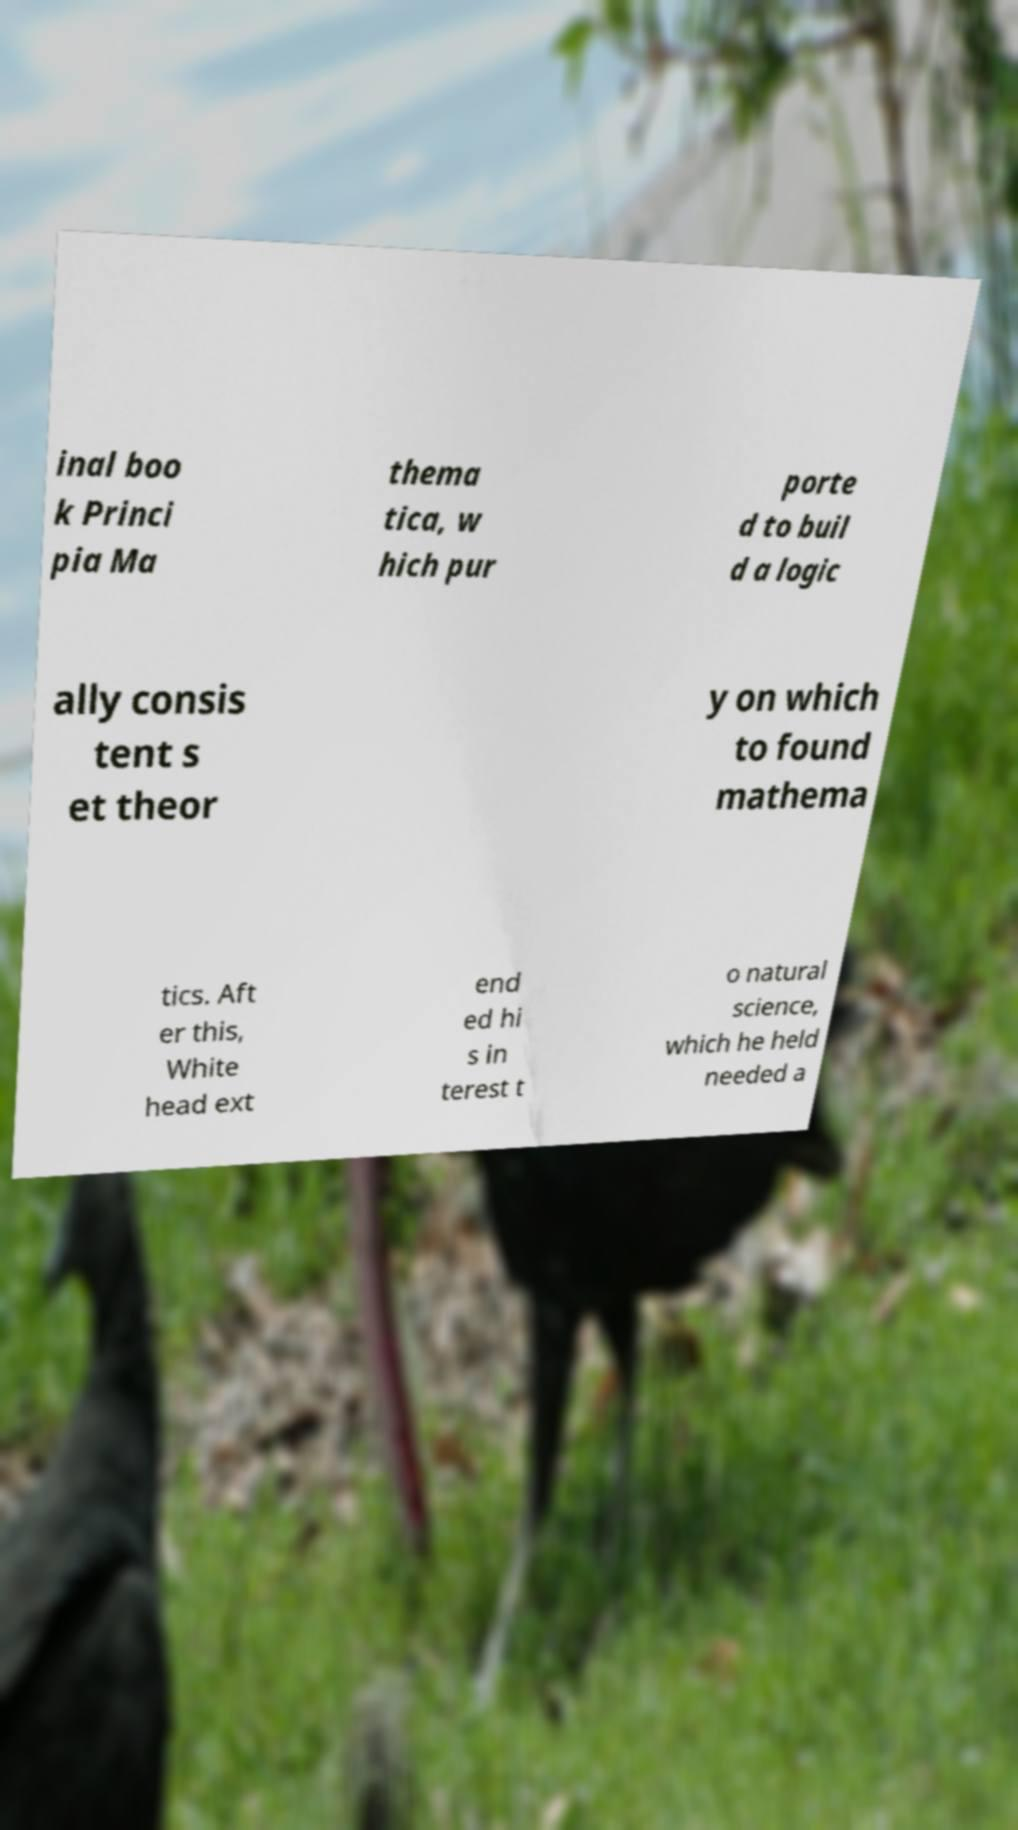Please read and relay the text visible in this image. What does it say? inal boo k Princi pia Ma thema tica, w hich pur porte d to buil d a logic ally consis tent s et theor y on which to found mathema tics. Aft er this, White head ext end ed hi s in terest t o natural science, which he held needed a 